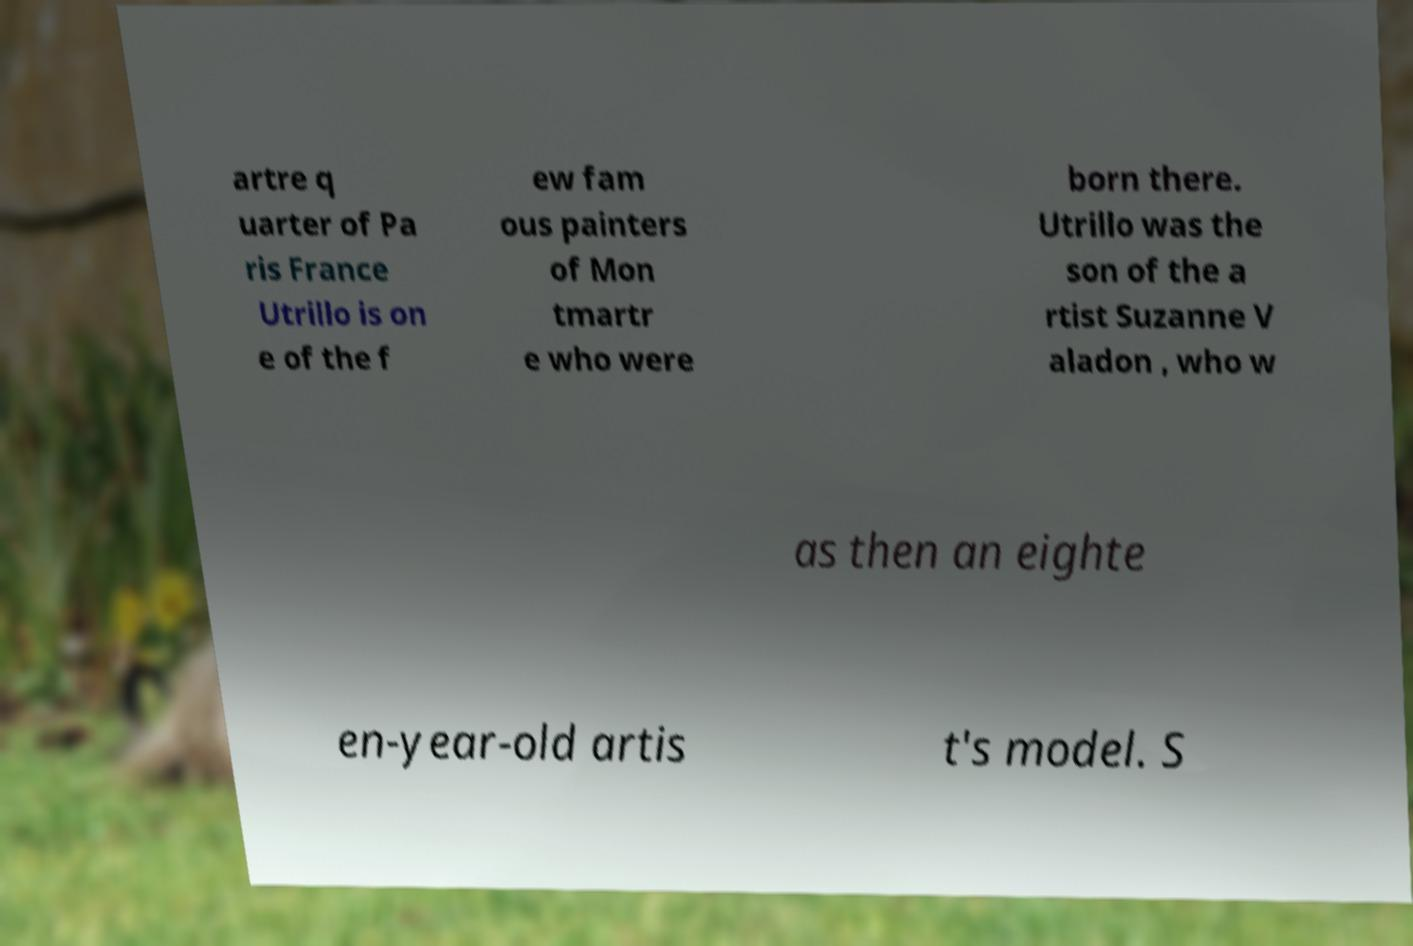What messages or text are displayed in this image? I need them in a readable, typed format. artre q uarter of Pa ris France Utrillo is on e of the f ew fam ous painters of Mon tmartr e who were born there. Utrillo was the son of the a rtist Suzanne V aladon , who w as then an eighte en-year-old artis t's model. S 